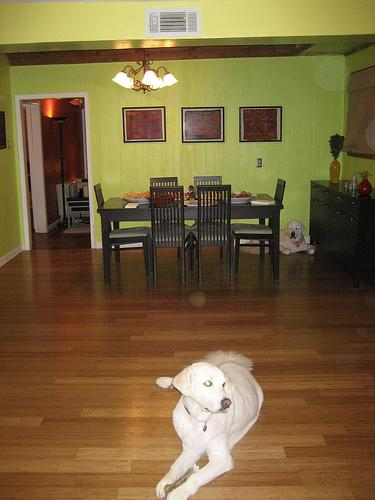Identify the color and type of floor in the image. The floor is brown and made of wood. Briefly describe the sentiment conveyed by the image. The image conveys a cozy, warm, and inviting atmosphere with the presence of dogs and a well-set dining area. What kind of animal can be seen in the image and on what surface are they situated? There are two dogs, one large white dog and a yellow lab, both sitting on a hardwood floor. In a detailed manner, describe the room in the image and the major pieces of furniture present. The room is a dining area with a dining room table and six chairs, a dark wooden hutch, and dark brown kitchen cabinets. There are also three framed paintings and a black halogen floor lamp in the room. What unique features can be seen on the dogs in the image? One dog has a tag hanging around its neck and a collar, and its eye is reflecting light. The other dog is wearing a bandana and has a chewed bone. List the objects that can be found on the table. There is plenty of food on top of the black table, a green plant in a yellow vase, and a delicious meal. Identify any object in the image that can be associated with providing light. A ceiling lamp turned on and a black halogen floor lamp can be associated with providing light. How many vases are present in the image and what are their colors? There are three vases: a yellow vase, a red flower vase, and another red vase on the counter. Count and describe the distinct number of chairs, images hanging on the wall, and vases present in the image. There are six dinner chairs, three sets of images hanging on the wall with two to three pieces of art each, and three vases. What objects can be found hanging from the ceiling and inside the wall? There are lights hanging from the ceiling and a heating vent, as well as a gray vent and a white metal vent in the wall. A child is playing hide-and-seek behind the curtains, don't let them go unnoticed! There is no reference to a child or curtains in the provided image information, yet the instruction adds a playful, interactive element that makes viewers want to find this non-existent scene. Describe the flooring material in the image. brown wooden floor Could you point out the grandfather clock ticking away near the window? There is no reference to a grandfather clock or a window in the provided image information. Framing the instruction as a question engages the viewer to search for these non-existent objects. Is the heating vent of the room in the wall or on the floor? in the wall Choose the correct description of the dining setting in the image: (A) four chairs around a table, (B) six chairs around a table, or (C) eight chairs around a table. (B) six chairs around a table Are there any red elements in the image? If so, describe them. Yes, a red flower vase How many pieces of art are displayed on the wall? three What type of room is depicted in the image? dining room In a visual storytelling format, describe the scene in the image. The dining room was cozy and inviting, with a delicious meal set on the table. Family photos and artwork lined the walls while the friendly dogs played nearby on the wooden floor. Admire the stunning abstract painting hanging above the fireplace. There is no indication of a fireplace or an abstract painting in the image details provided. By using descriptive terms like "stunning," the instruction attempts to draw the viewer's attention to something that is not actually in the image. Are there any plants or flowers in the image? If so, describe their appearance and location. Yes, a green plant sticking out of a yellow vase on the counter. What is the color of the dog's collar? Not clearly visible, but it might be dark colored How many dogs are present on the floor in the image? two Write a short caption summarizing the setting of the image. A dining room with a wooden floor, a table with six chairs, and artwork on the wall. Can you spot the vibrant blue tablecloth draped across the table? No, it's not mentioned in the image. Identify the color of the vent in the image. gray What is the predominant color of the dining room table? black Look for the cat lounging on the couch in the corner. There is no mention of a cat or a couch in the image information provided, but the instruction still leads viewers to search for these non-existent objects. Describe the design of the lightswitch on the wall. It is a simple white lightswitch What is the dog wearing around its neck? tag If we place the following words over the image: "vent," "dog," "chew bone," and "flower vase," which word would most likely be placed over coordinates (150, 350)? dog In the image, what is on the table? plenty of food 